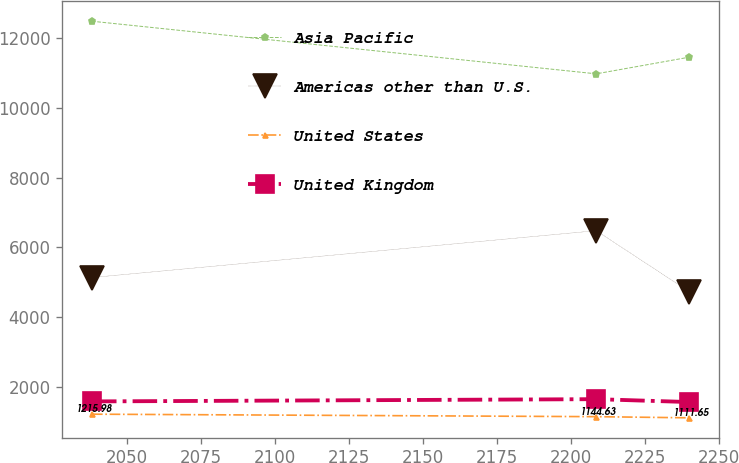Convert chart to OTSL. <chart><loc_0><loc_0><loc_500><loc_500><line_chart><ecel><fcel>Asia Pacific<fcel>Americas other than U.S.<fcel>United States<fcel>United Kingdom<nl><fcel>2038.22<fcel>12482.5<fcel>5134.37<fcel>1215.98<fcel>1582.09<nl><fcel>2208.6<fcel>10974.4<fcel>6477.44<fcel>1144.63<fcel>1646.49<nl><fcel>2239.97<fcel>11451.1<fcel>4732.02<fcel>1111.65<fcel>1564.01<nl></chart> 